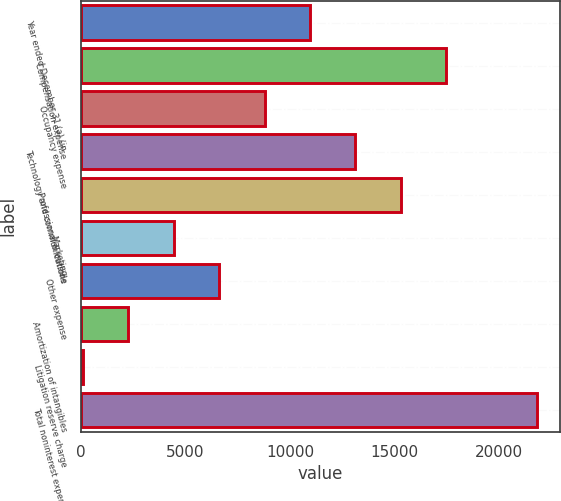Convert chart to OTSL. <chart><loc_0><loc_0><loc_500><loc_500><bar_chart><fcel>Year ended December 31 (a) (in<fcel>Compensation expense<fcel>Occupancy expense<fcel>Technology and communications<fcel>Professional & outside<fcel>Marketing<fcel>Other expense<fcel>Amortization of intangibles<fcel>Litigation reserve charge<fcel>Total noninterest expense<nl><fcel>10958<fcel>17472.8<fcel>8786.4<fcel>13129.6<fcel>15301.2<fcel>4443.2<fcel>6614.8<fcel>2271.6<fcel>100<fcel>21816<nl></chart> 